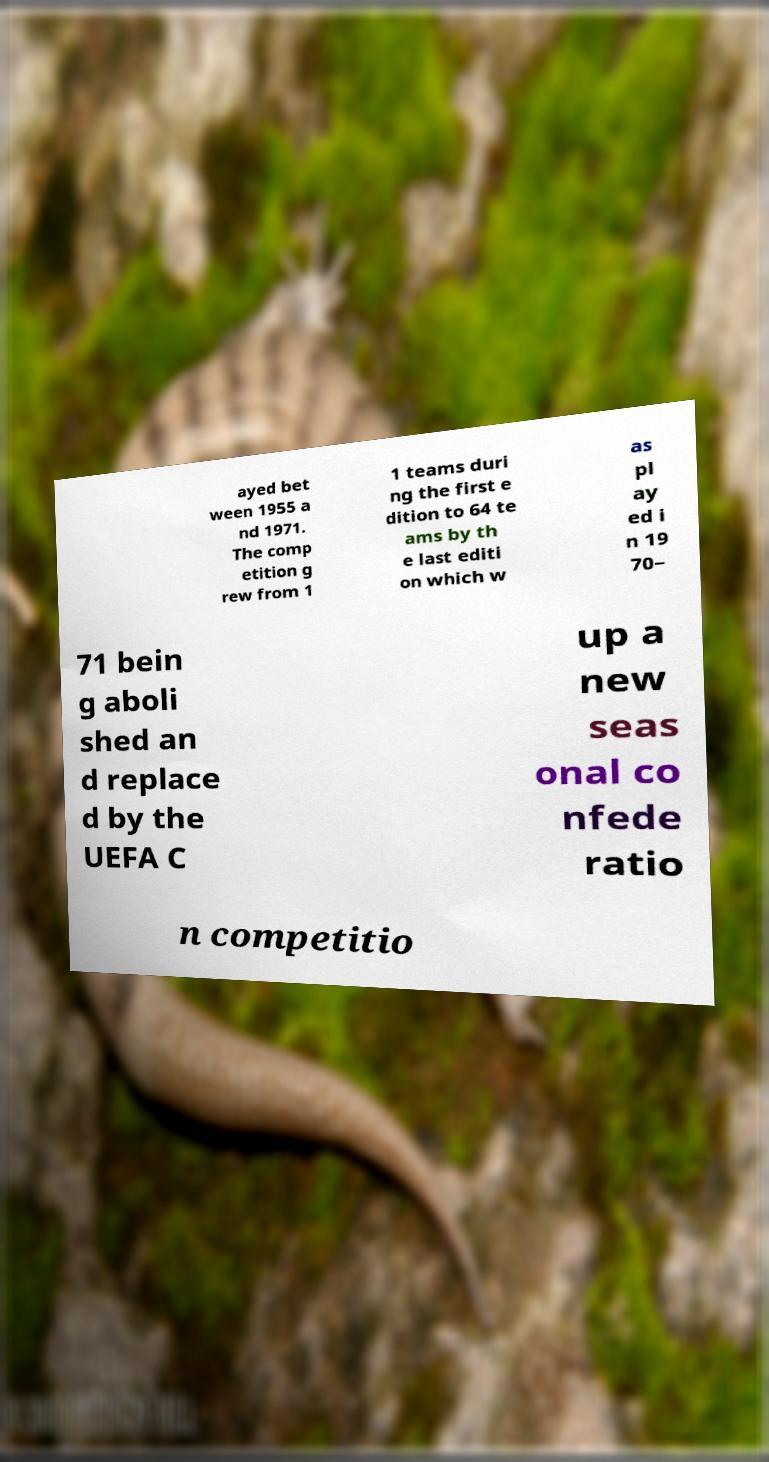What messages or text are displayed in this image? I need them in a readable, typed format. ayed bet ween 1955 a nd 1971. The comp etition g rew from 1 1 teams duri ng the first e dition to 64 te ams by th e last editi on which w as pl ay ed i n 19 70– 71 bein g aboli shed an d replace d by the UEFA C up a new seas onal co nfede ratio n competitio 